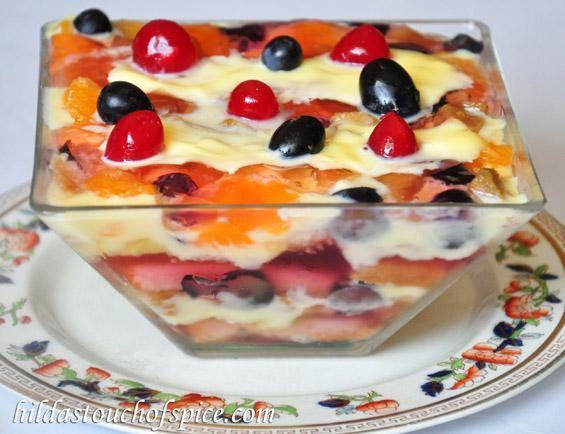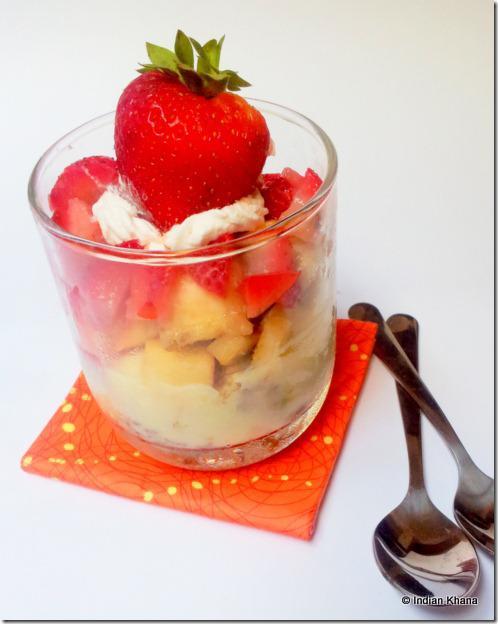The first image is the image on the left, the second image is the image on the right. For the images shown, is this caption "There are spoons resting next to a cup of trifle." true? Answer yes or no. Yes. 